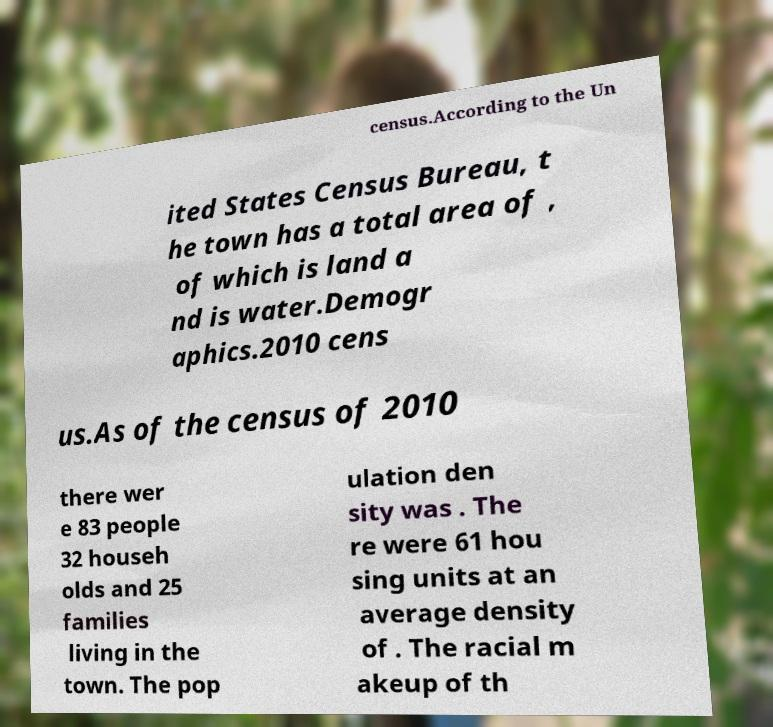Could you assist in decoding the text presented in this image and type it out clearly? census.According to the Un ited States Census Bureau, t he town has a total area of , of which is land a nd is water.Demogr aphics.2010 cens us.As of the census of 2010 there wer e 83 people 32 househ olds and 25 families living in the town. The pop ulation den sity was . The re were 61 hou sing units at an average density of . The racial m akeup of th 